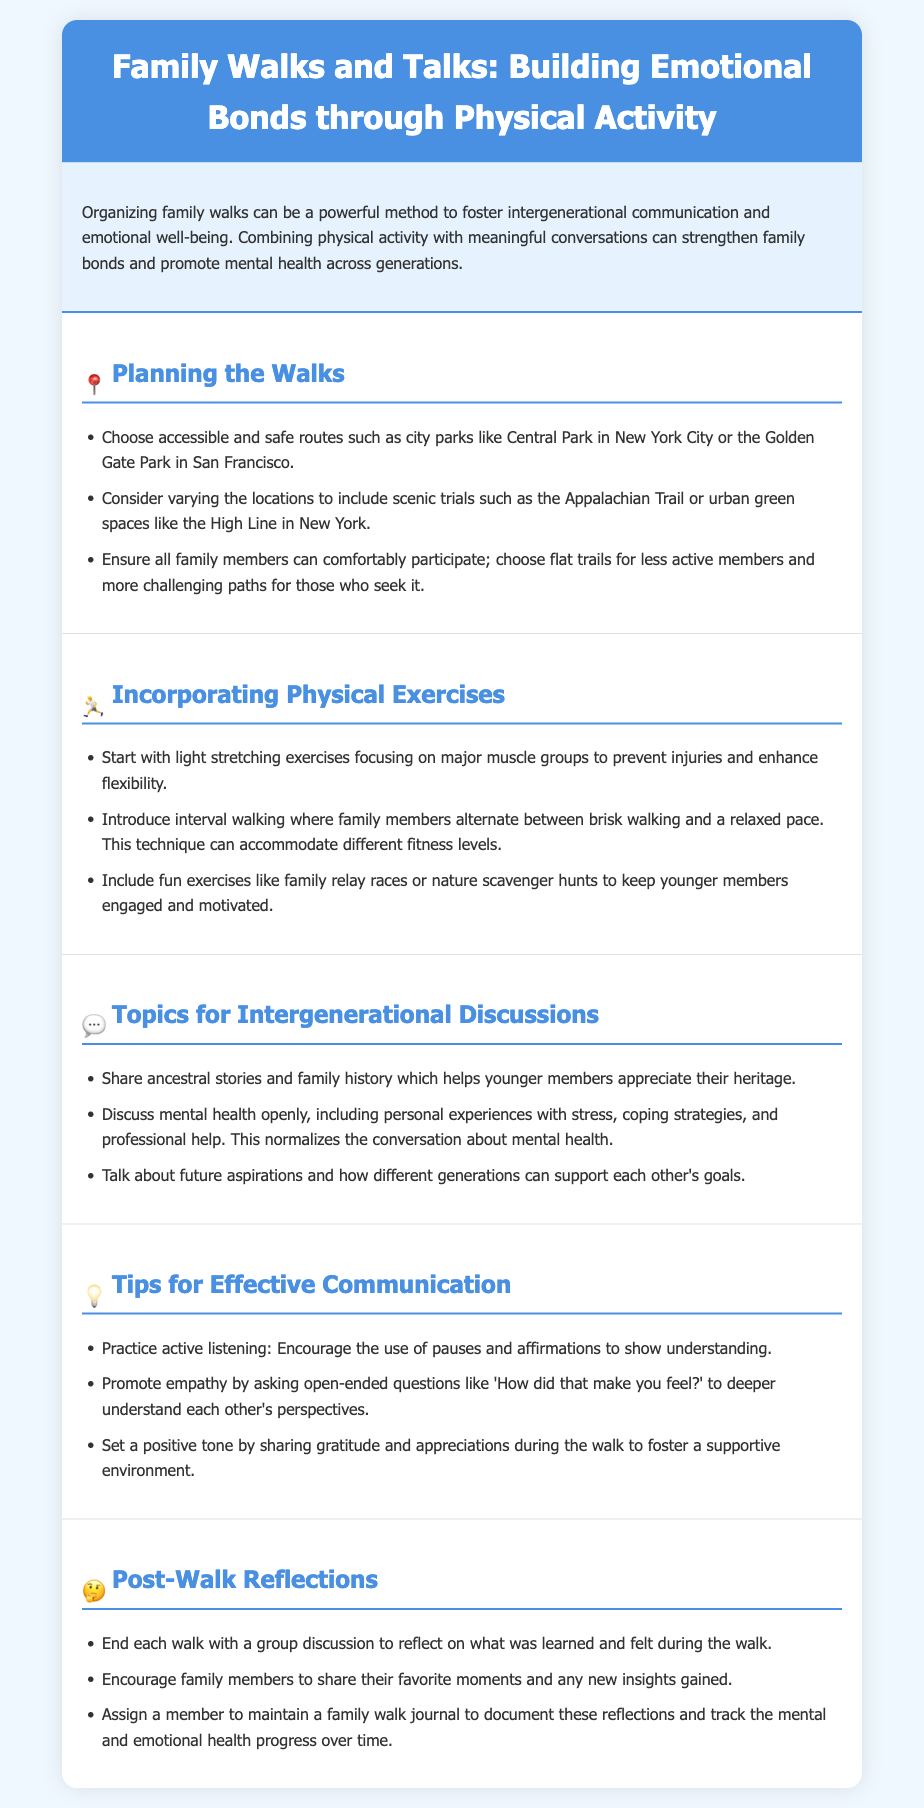What are suggested routes for family walks? The document lists accessible and safe routes such as Central Park in New York City and Golden Gate Park in San Francisco.
Answer: Central Park, Golden Gate Park What is an activity to start the walk? It mentions starting with light stretching exercises focusing on major muscle groups to prevent injuries and enhance flexibility.
Answer: Light stretching What is one topic for intergenerational discussions? It suggests sharing ancestral stories and family history to help younger members appreciate their heritage.
Answer: Ancestral stories What should family members practice during communication? The document advises practicing active listening and encourages the use of pauses and affirmations to show understanding.
Answer: Active listening What is included in post-walk reflections? Ending the walk with a group discussion to reflect on what was learned and felt during the walk is mentioned.
Answer: Group discussion How can family members document their reflections? It states that assigning a member to maintain a family walk journal to document reflections is a method suggested.
Answer: Family walk journal What type of exercises can keep younger members engaged? The document mentions including fun exercises like family relay races or nature scavenger hunts.
Answer: Family relay races What is a tip to promote empathy during walks? It suggests asking open-ended questions like 'How did that make you feel?' to deepen understanding of each other's perspectives.
Answer: Open-ended questions What is one goal of organizing family walks? The purpose is to foster intergenerational communication and emotional well-being.
Answer: Foster communication and well-being 